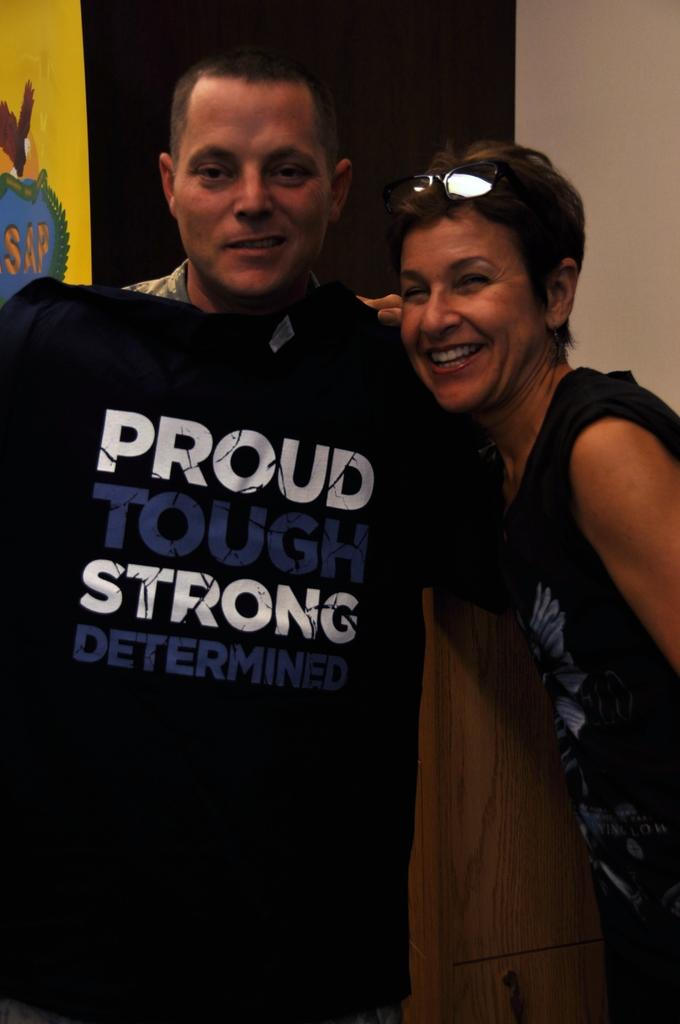Who or what can be seen in the image? There are people in the image. Can you describe any specific clothing item in the image? There is a t-shirt with writing on it. What type of protective eyewear is present in the image? There are goggles in the image. Are there any other objects visible in the image that are not specified? Yes, there are unspecified objects in the image. What type of basin is being used by the daughter in the image? There is no basin or daughter present in the image. 